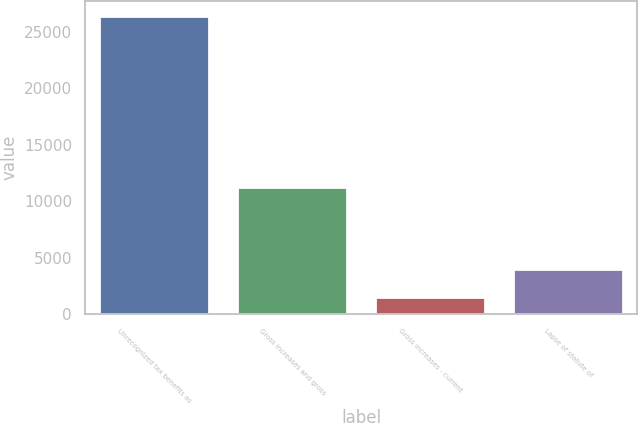<chart> <loc_0><loc_0><loc_500><loc_500><bar_chart><fcel>Unrecognized tax benefits as<fcel>Gross increases and gross<fcel>Gross increases - current<fcel>Lapse of statute of<nl><fcel>26381<fcel>11268<fcel>1483<fcel>3972.8<nl></chart> 